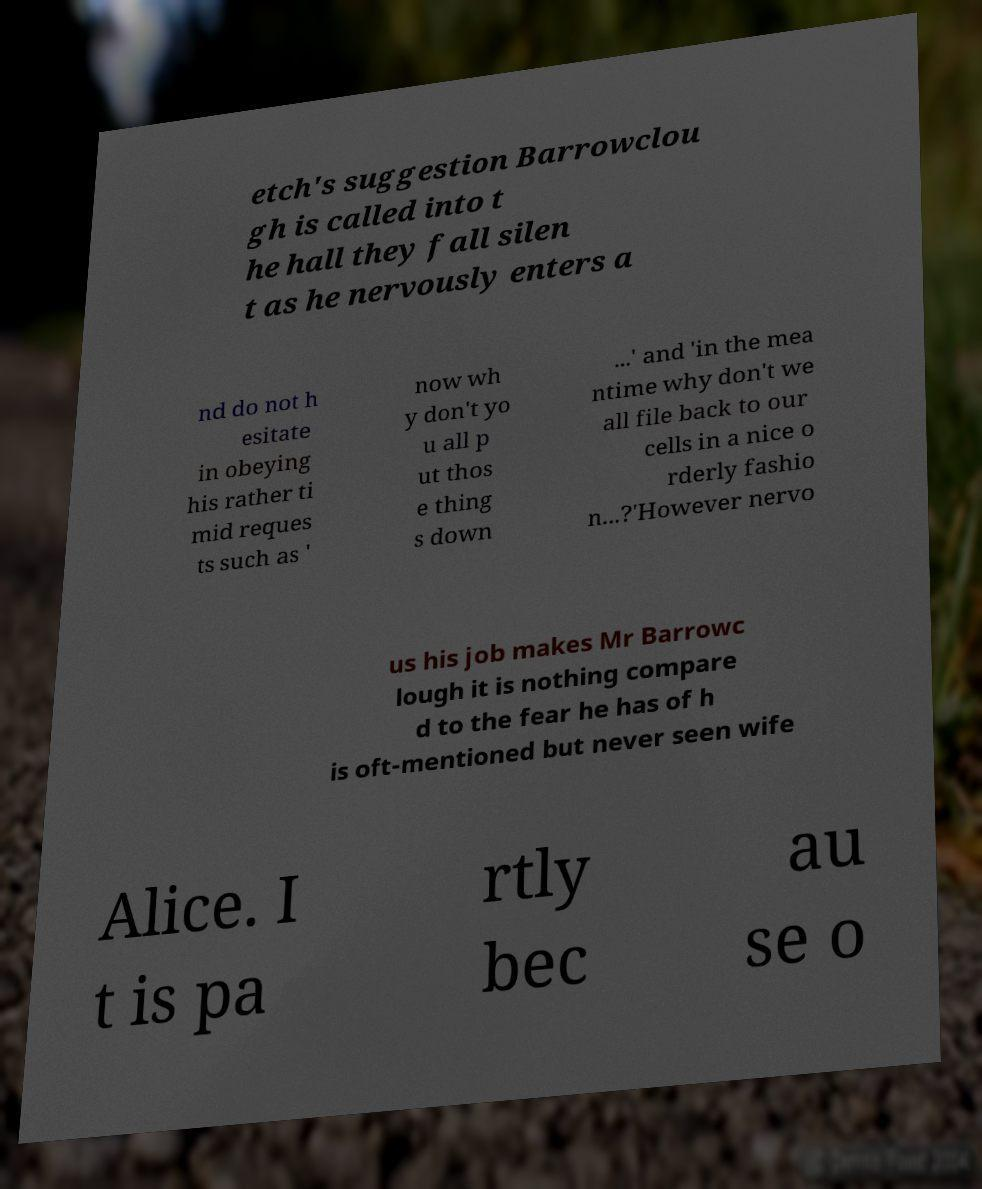For documentation purposes, I need the text within this image transcribed. Could you provide that? etch's suggestion Barrowclou gh is called into t he hall they fall silen t as he nervously enters a nd do not h esitate in obeying his rather ti mid reques ts such as ' now wh y don't yo u all p ut thos e thing s down ...' and 'in the mea ntime why don't we all file back to our cells in a nice o rderly fashio n...?'However nervo us his job makes Mr Barrowc lough it is nothing compare d to the fear he has of h is oft-mentioned but never seen wife Alice. I t is pa rtly bec au se o 